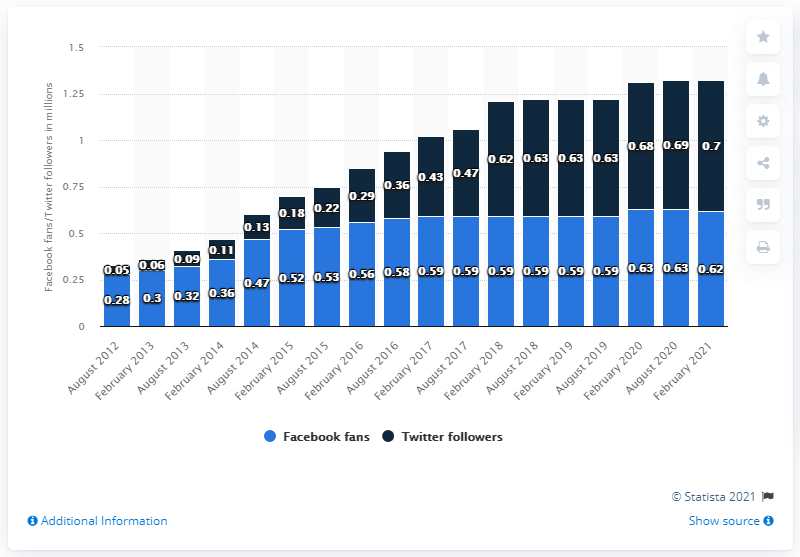Identify some key points in this picture. As of February 2021, the Jacksonville Jaguars football team had 0.62 million Facebook fans. 